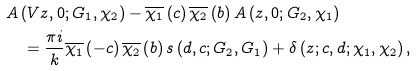<formula> <loc_0><loc_0><loc_500><loc_500>& A \left ( V z , 0 ; G _ { 1 } , \chi _ { 2 } \right ) - \overline { \chi _ { 1 } } \left ( c \right ) \overline { \chi _ { 2 } } \left ( b \right ) A \left ( z , 0 ; G _ { 2 } , \chi _ { 1 } \right ) \\ & \quad = \frac { \pi i } { k } \overline { \chi _ { 1 } } \left ( - c \right ) \overline { \chi _ { 2 } } \left ( b \right ) s \left ( d , c ; G _ { 2 } , G _ { 1 } \right ) + \delta \left ( z ; c , d ; \chi _ { 1 } , \chi _ { 2 } \right ) ,</formula> 